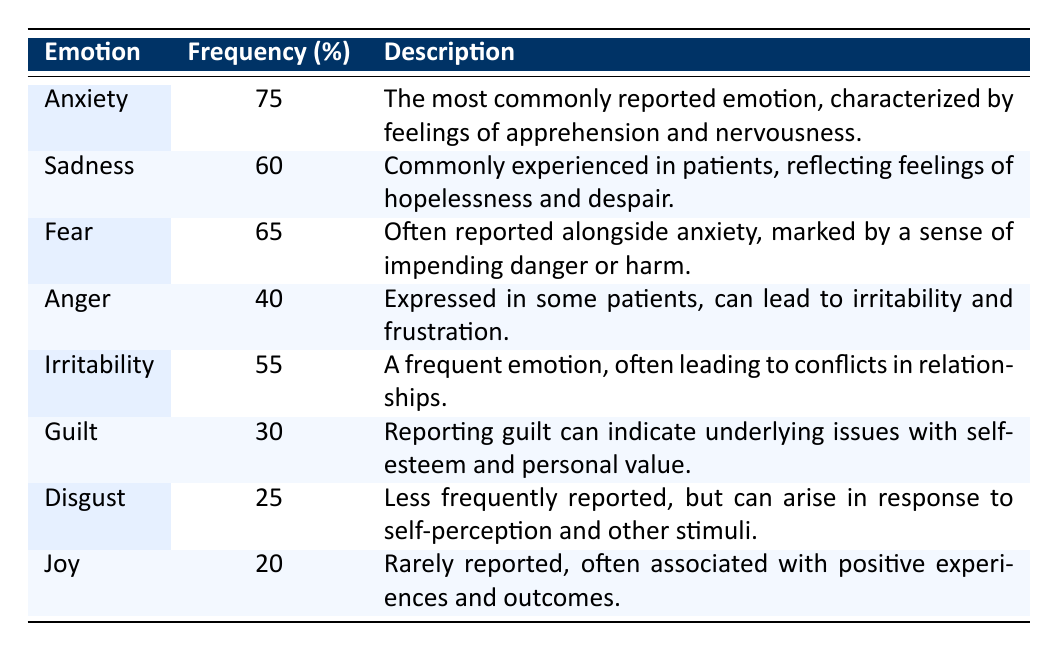What is the most commonly reported emotion in patients with anxiety disorders? From the table, "Anxiety" has the highest frequency percentage of 75%, indicating it is the most commonly reported emotion among patients with anxiety disorders.
Answer: Anxiety What emotion is reported by the least percentage of patients? According to the table, "Joy" is reported by only 20% of patients, making it the least frequently reported emotion.
Answer: Joy Is guilt experienced by more than half of the patients? The table shows that the frequency of "Guilt" is 30%, which is less than 50%, indicating that it is not experienced by more than half of the patients.
Answer: No What is the combined frequency percent of fear and anger? From the table, "Fear" has a frequency of 65% and "Anger" has a frequency of 40%. Combining these gives 65 + 40 = 105%.
Answer: 105% How does the percent of patients reporting sadness compare to the percent reporting guilt? The table shows that "Sadness" is reported by 60% of patients, while "Guilt" is reported by 30%. The difference between them is 60 - 30 = 30%, indicating that sadness is reported more frequently.
Answer: 30% What percentage of patients report both joy and guilt? The frequency for "Joy" is 20% and for "Guilt" is 30%. These values do not sum directly since they are independent frequencies. Therefore, to find what percentage reports either joy or guilt, we recognize that these are distinct emotions with their own percentages. Thus, the combined report is 20 + 30 = 50%, but since patients can report multiple emotions, we cannot combine them without knowing overlaps. So we conclude that 50% could be affected.
Answer: 50% How many emotions are reported by at least half of the patients? Based on the table, emotions reported by at least half of the patients are "Anxiety" (75%), "Sadness" (60%), "Fear" (65%), and "Irritability" (55%). This gives a total of four emotions reported by at least half of the patients.
Answer: 4 Which emotion has a frequency percent lower than that of irritability? The table shows that "Guilt" (30%), "Disgust" (25%), and "Joy" (20%) all have percentages lower than "Irritability" (55%). Therefore, these three emotions are the ones reported less frequently than irritability.
Answer: Guilt, Disgust, Joy Which emotion, besides anxiety, has the highest frequency percent? The table indicates that "Fear" is reported by 65% of patients, which is the highest frequency after "Anxiety" (75%).
Answer: Fear 